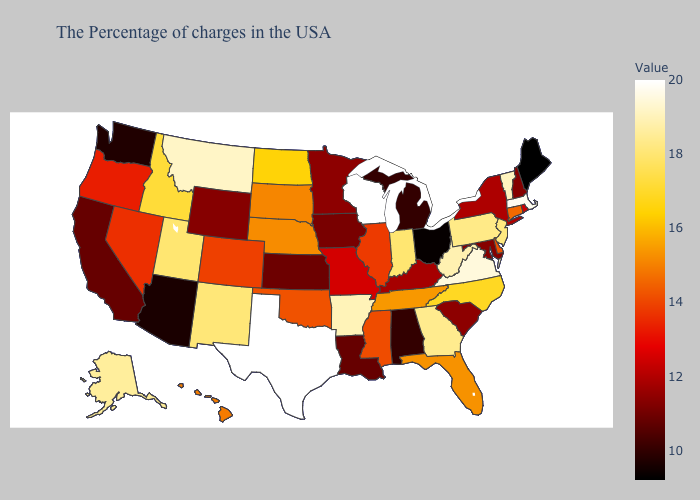Does Illinois have a higher value than Pennsylvania?
Concise answer only. No. Does West Virginia have the highest value in the South?
Concise answer only. No. Which states hav the highest value in the West?
Be succinct. Montana. Does Idaho have a lower value than Montana?
Concise answer only. Yes. Which states have the highest value in the USA?
Short answer required. Wisconsin, Texas. Does Colorado have a higher value than Iowa?
Quick response, please. Yes. 